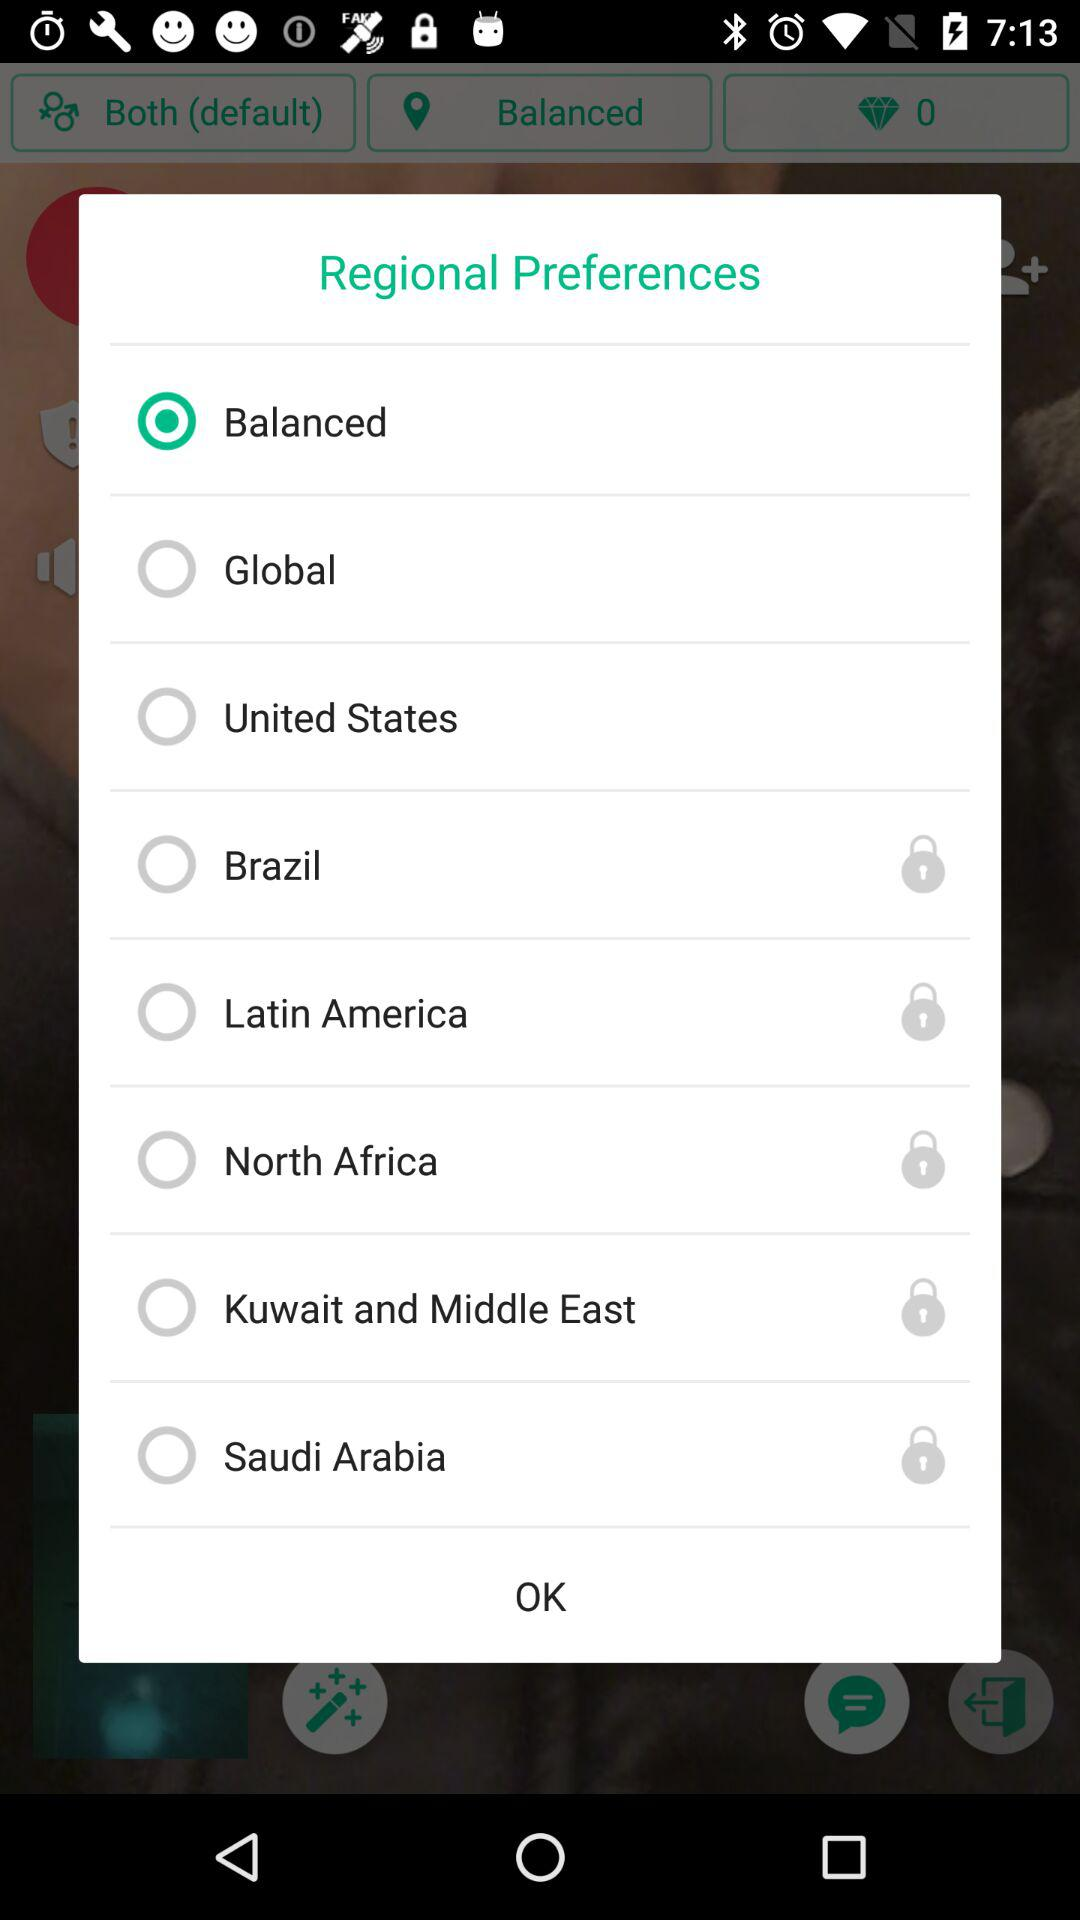What option is selected in "Regional Preferences"? The selected option is "Balanced". 